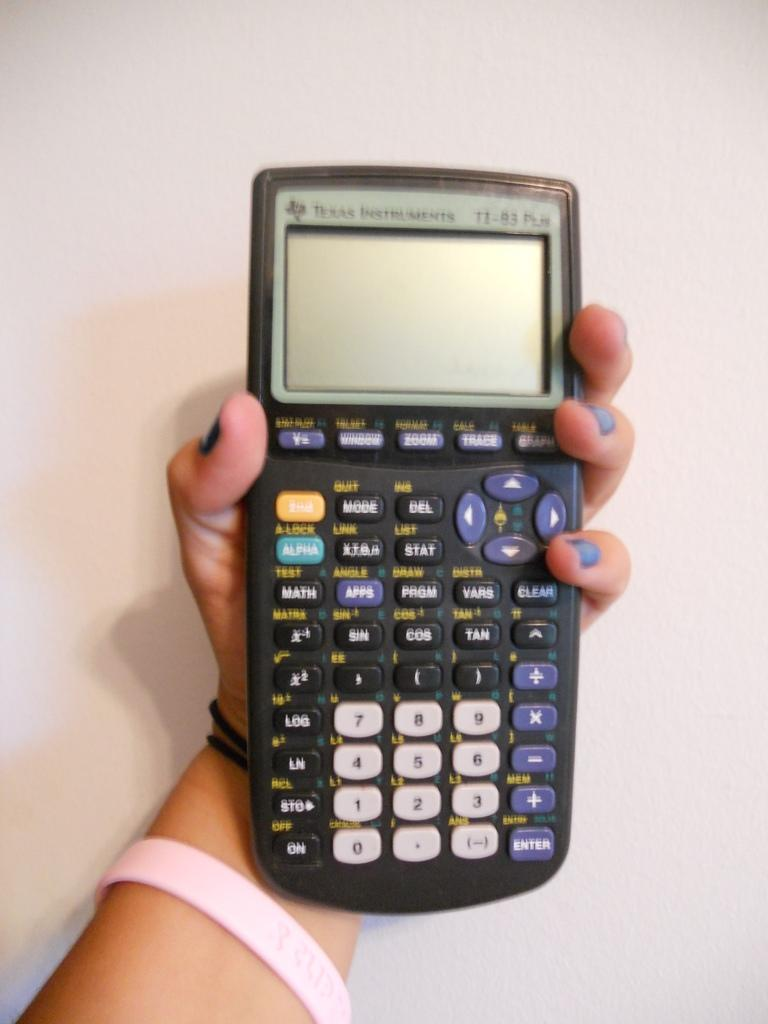<image>
Give a short and clear explanation of the subsequent image. hand holding a texas instruments TI-83 graphing calculator 